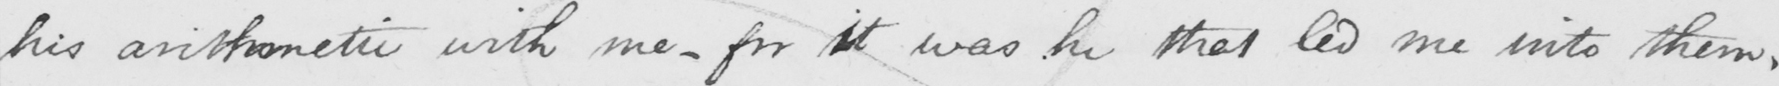Please provide the text content of this handwritten line. his arithmetic with me  _  for it was he that led me into them . 